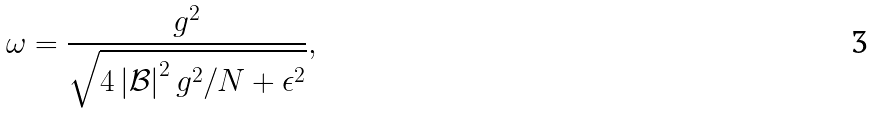Convert formula to latex. <formula><loc_0><loc_0><loc_500><loc_500>\omega = \frac { g ^ { 2 } } { \sqrt { 4 \left | \mathcal { B } \right | ^ { 2 } g ^ { 2 } / N + \epsilon ^ { 2 } } } ,</formula> 